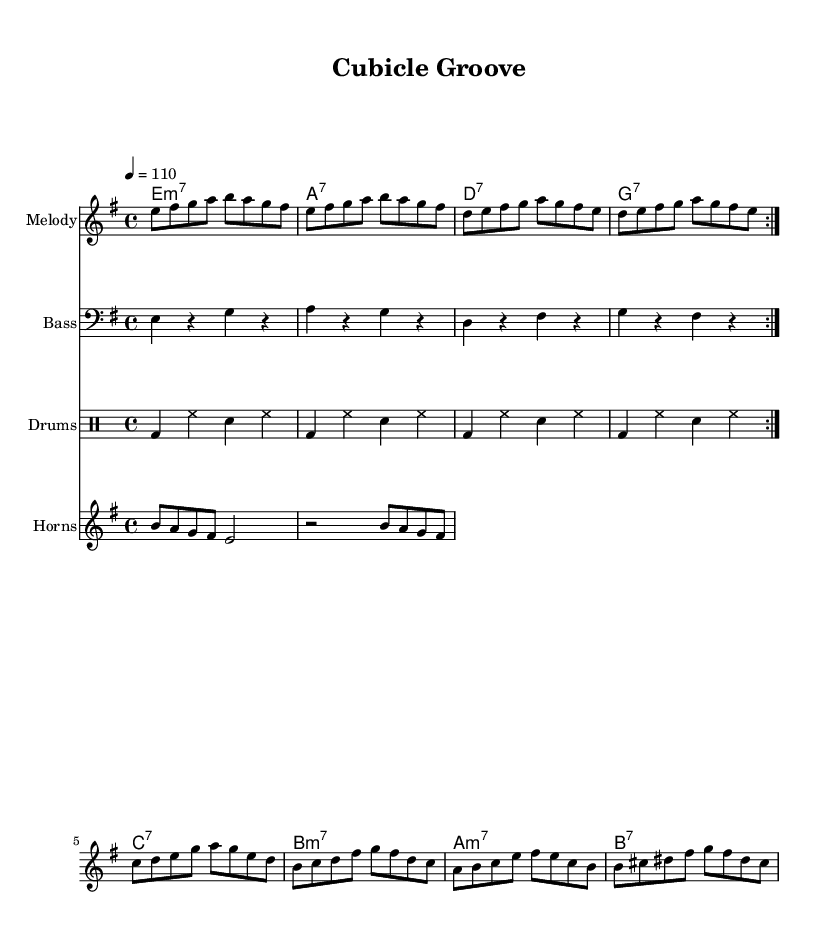What is the key signature of this music? The key signature of the piece is E minor, which typically has one sharp (F#) noted on the staff. This key is indicated at the beginning of the score and is confirmed by the notes in the melody.
Answer: E minor What is the time signature of this music? The time signature is 4/4, meaning there are four beats in each measure and the quarter note receives one beat. This is indicated at the beginning of the score, and the rhythmic grouping throughout supports this.
Answer: 4/4 What is the tempo marking for this piece? The tempo marking indicates the speed of the piece and is set to 110 beats per minute (bpm), which is stated in the tempo section at the beginning of the score.
Answer: 110 Which instrument is playing the melody? The melody is played by a staff labeled "Melody," which is a clear indication that this part is specifically designated for a melodic instrument or voice.
Answer: Melody How many times is the main melody repeated? The symbol "volta 2" indicates that the melody is repeated two times, and it is evident in the structure of the melody where the repeated sections are visually marked.
Answer: 2 What type of chords are used in the chord progression? The chord progression consists of seventh chords, as indicated by the ":7" notation in the chord names written above the melody. These chords add a funkier character to the harmony typical of funk music.
Answer: seventh chords What rhythmic pattern is used in the drums? The drums use a consistent pattern of bass drum and hi-hat, alternating with snare, which follows a standard funk groove often characterized by this rhythmic interplay. This pattern is notated under the drum staff.
Answer: funk groove 